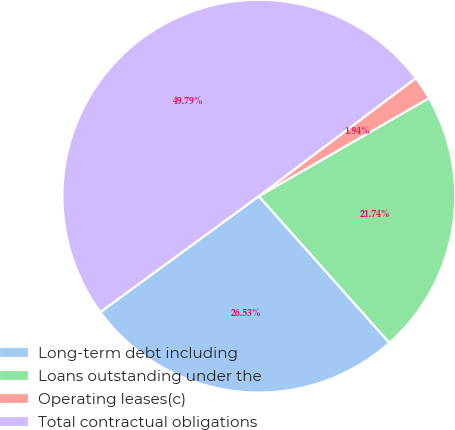Convert chart. <chart><loc_0><loc_0><loc_500><loc_500><pie_chart><fcel>Long-term debt including<fcel>Loans outstanding under the<fcel>Operating leases(c)<fcel>Total contractual obligations<nl><fcel>26.53%<fcel>21.74%<fcel>1.94%<fcel>49.79%<nl></chart> 